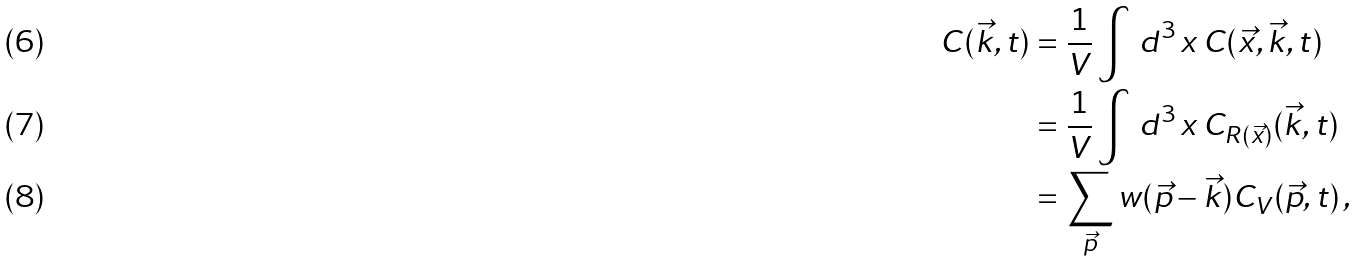<formula> <loc_0><loc_0><loc_500><loc_500>C ( \vec { k } , t ) & = \frac { 1 } { V } \int \, d ^ { 3 } \, x \, C ( \vec { x } , \vec { k } , t ) \\ & = \frac { 1 } { V } \int \, d ^ { 3 } \, x \, C _ { R ( \vec { x } ) } ( \vec { k } , t ) \\ & = \sum _ { \vec { p } } w ( \vec { p } - \vec { k } ) C _ { V } ( \vec { p } , t ) \, ,</formula> 